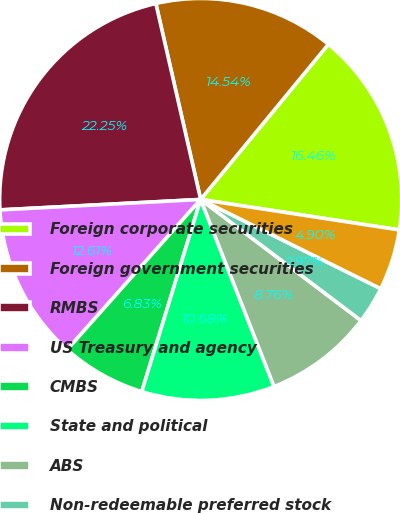Convert chart. <chart><loc_0><loc_0><loc_500><loc_500><pie_chart><fcel>Foreign corporate securities<fcel>Foreign government securities<fcel>RMBS<fcel>US Treasury and agency<fcel>CMBS<fcel>State and political<fcel>ABS<fcel>Non-redeemable preferred stock<fcel>Total equity securities<nl><fcel>16.46%<fcel>14.54%<fcel>22.25%<fcel>12.61%<fcel>6.83%<fcel>10.68%<fcel>8.76%<fcel>2.97%<fcel>4.9%<nl></chart> 